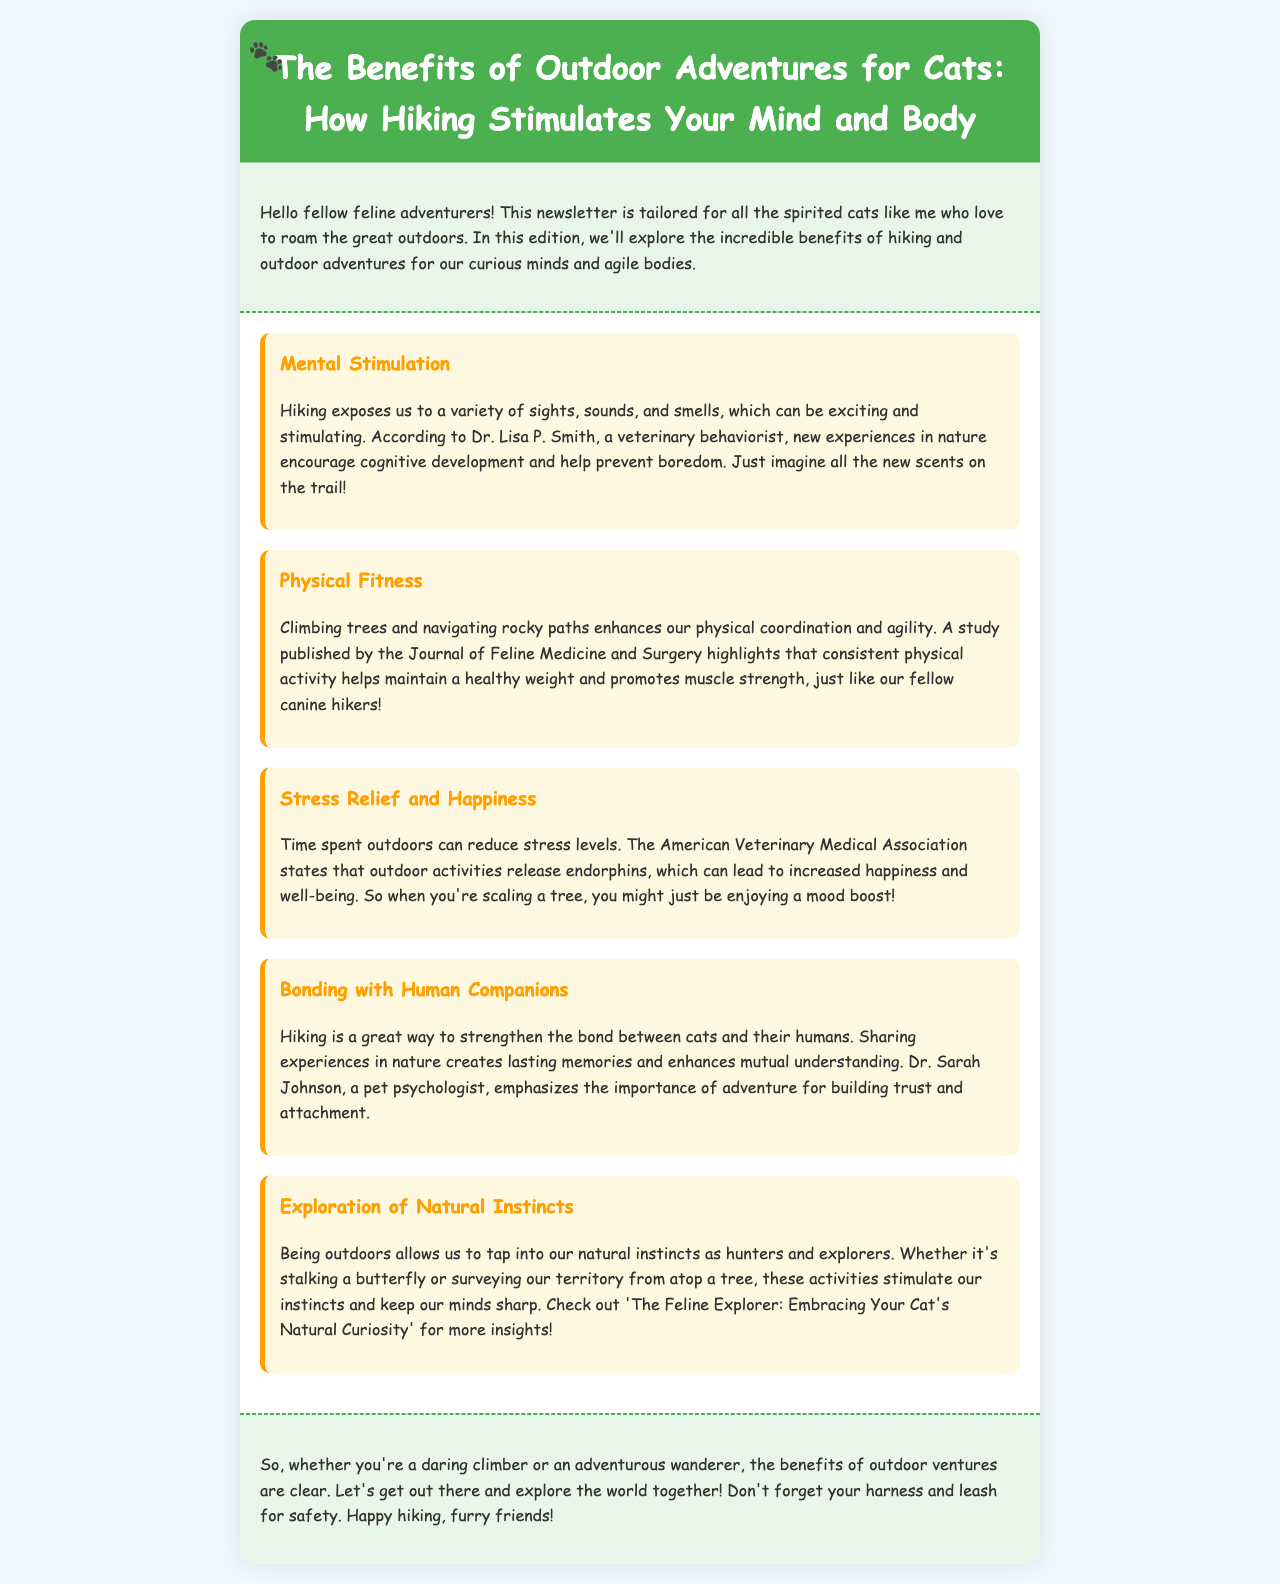What is the title of the newsletter? The title is the main heading at the top of the document that describes the content, which is "The Benefits of Outdoor Adventures for Cats: How Hiking Stimulates Your Mind and Body."
Answer: The Benefits of Outdoor Adventures for Cats: How Hiking Stimulates Your Mind and Body Who is Dr. Lisa P. Smith? Dr. Lisa P. Smith is identified in the document as a veterinary behaviorist who discusses the benefits of mental stimulation from hiking.
Answer: A veterinary behaviorist What does climbing trees enhance? The document states that climbing trees enhances physical coordination and agility.
Answer: Physical coordination and agility Which organization states that outdoor activities release endorphins? The American Veterinary Medical Association is mentioned as the organization that states outdoor activities release endorphins.
Answer: American Veterinary Medical Association What is one benefit of hiking mentioned in relation to human companions? The document highlights that hiking strengthens the bond between cats and their humans.
Answer: Strengthens the bond What activity stimulates our natural instincts as hunters? The document mentions stalking a butterfly or surveying from atop a tree as activities that stimulate our natural instincts.
Answer: Stalking a butterfly or surveying from atop a tree What color is the background of the benefits section? The benefits section has a white background, as indicated in the styling of the document.
Answer: White What should cats not forget when hiking? The document advises cats to not forget their harness and leash for safety when hiking.
Answer: Harness and leash 